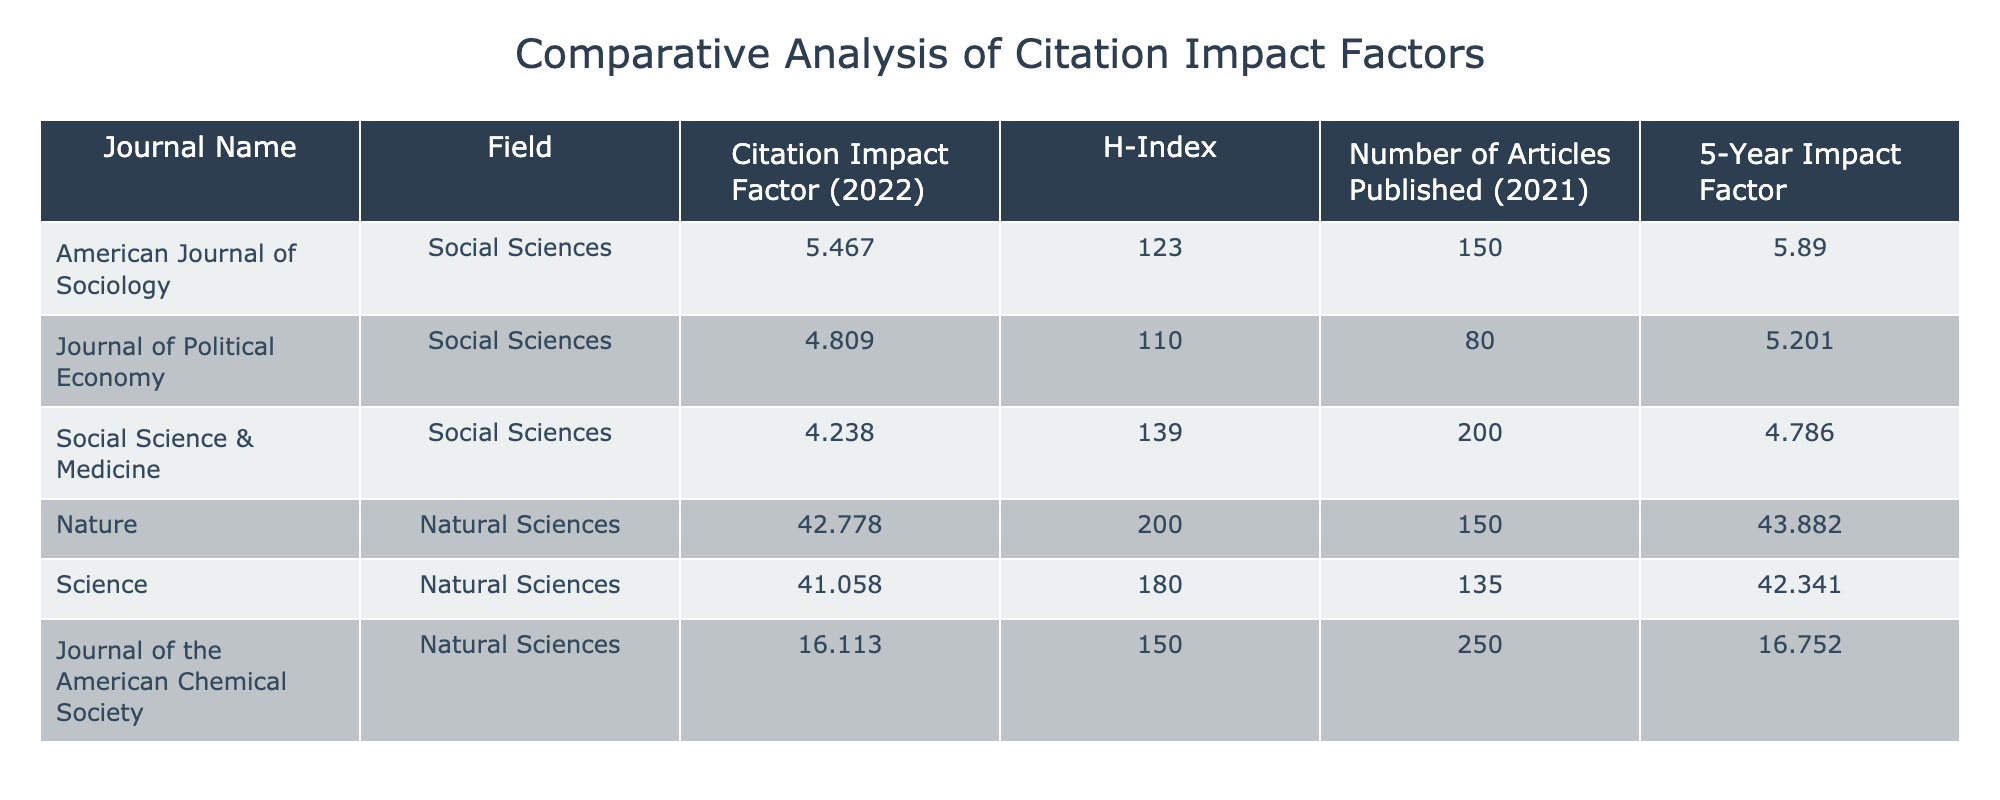What is the Citation Impact Factor of the Journal of Political Economy? The table lists the Citation Impact Factor for each journal, and for the Journal of Political Economy, it is explicitly stated as 4.809.
Answer: 4.809 Which journal has the highest H-Index? By examining the H-Index values in the table, the journal with the highest H-Index is Nature, which has an H-Index of 200.
Answer: Nature What is the average Citation Impact Factor for journals in Social Sciences? To find the average, add the Citation Impact Factors of the three Social Sciences journals: 5.467 + 4.809 + 4.238 = 14.514. Then, divide by 3 (the number of journals): 14.514 / 3 = 4.838.
Answer: 4.838 Is the 5-Year Impact Factor of the American Journal of Sociology greater than that of the Journal of the American Chemical Society? The 5-Year Impact Factor of the American Journal of Sociology is 5.890, while that of the Journal of the American Chemical Society is 16.752. Since 5.890 is less than 16.752, the statement is false.
Answer: No What is the difference between the Citation Impact Factor of Nature and Social Science & Medicine? The Citation Impact Factor of Nature is 42.778, and that of Social Science & Medicine is 4.238. The difference is 42.778 - 4.238 = 38.540.
Answer: 38.540 Which journal has the lowest Number of Articles Published? Reviewing the Number of Articles Published column, the Journal of Political Economy has the lowest number, with 80 articles published.
Answer: Journal of Political Economy Is it true that all Natural Sciences journals have an H-Index above 100? Checking the H-Index values of the Natural Sciences journals, Nature has an H-Index of 200, Science has 180, and the Journal of the American Chemical Society has 150. Therefore, all H-Index values are above 100, making the statement true.
Answer: Yes What is the total number of articles published across all journals in the table? To find the total, sum the Number of Articles Published for each journal: 150 + 80 + 200 + 150 + 135 + 250 = 1065.
Answer: 1065 Which field has a higher average 5-Year Impact Factor, Social Sciences or Natural Sciences? Calculate the average for each field. For Social Sciences: (5.890 + 5.201 + 4.786) / 3 = 5.293. For Natural Sciences: (43.882 + 42.341 + 16.752) / 3 = 34.325. Since 5.293 < 34.325, Natural Sciences has a higher average.
Answer: Natural Sciences 